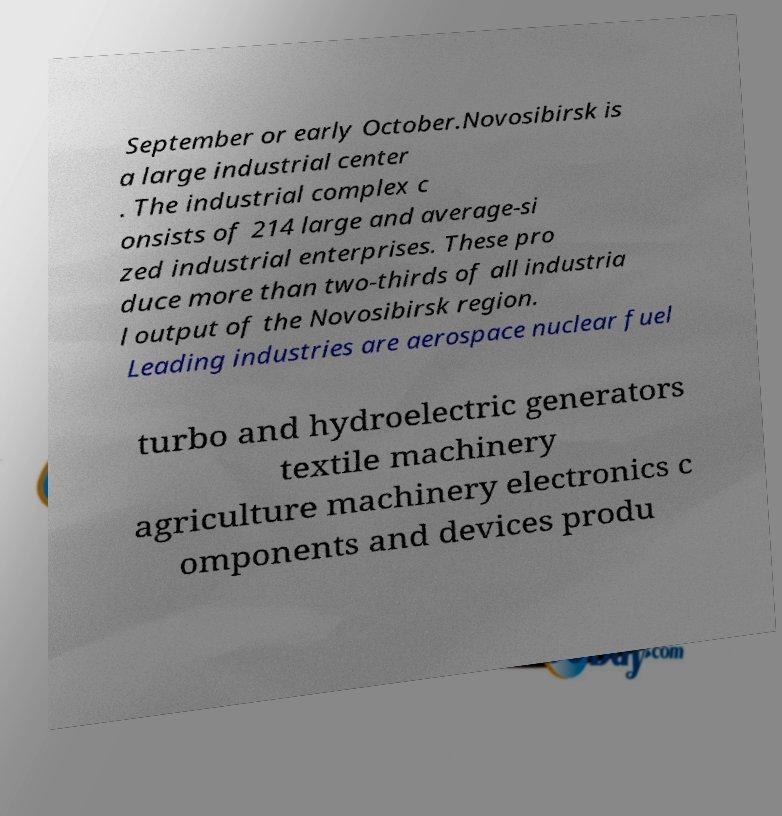Please identify and transcribe the text found in this image. September or early October.Novosibirsk is a large industrial center . The industrial complex c onsists of 214 large and average-si zed industrial enterprises. These pro duce more than two-thirds of all industria l output of the Novosibirsk region. Leading industries are aerospace nuclear fuel turbo and hydroelectric generators textile machinery agriculture machinery electronics c omponents and devices produ 